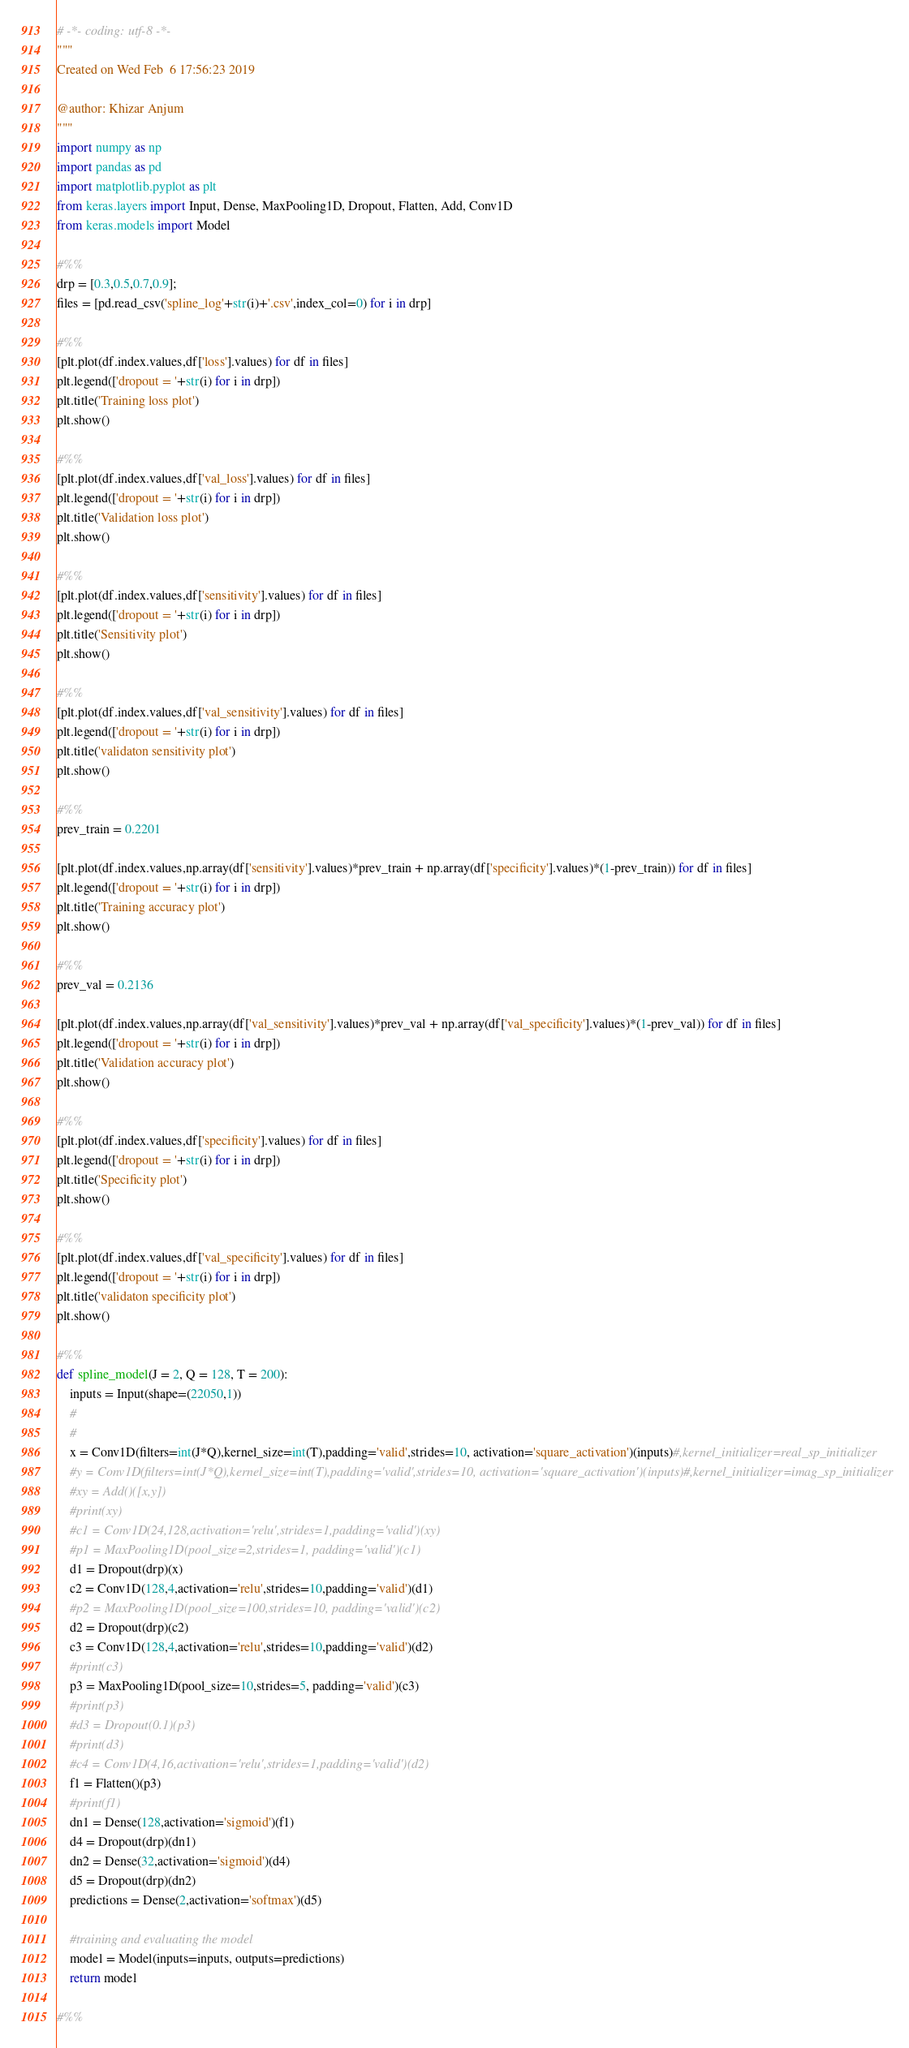Convert code to text. <code><loc_0><loc_0><loc_500><loc_500><_Python_># -*- coding: utf-8 -*-
"""
Created on Wed Feb  6 17:56:23 2019

@author: Khizar Anjum
"""
import numpy as np
import pandas as pd
import matplotlib.pyplot as plt
from keras.layers import Input, Dense, MaxPooling1D, Dropout, Flatten, Add, Conv1D
from keras.models import Model

#%%
drp = [0.3,0.5,0.7,0.9];
files = [pd.read_csv('spline_log'+str(i)+'.csv',index_col=0) for i in drp]

#%%
[plt.plot(df.index.values,df['loss'].values) for df in files]
plt.legend(['dropout = '+str(i) for i in drp])
plt.title('Training loss plot')
plt.show()

#%%
[plt.plot(df.index.values,df['val_loss'].values) for df in files]
plt.legend(['dropout = '+str(i) for i in drp])
plt.title('Validation loss plot')
plt.show()

#%%
[plt.plot(df.index.values,df['sensitivity'].values) for df in files]
plt.legend(['dropout = '+str(i) for i in drp])
plt.title('Sensitivity plot')
plt.show()

#%%
[plt.plot(df.index.values,df['val_sensitivity'].values) for df in files]
plt.legend(['dropout = '+str(i) for i in drp])
plt.title('validaton sensitivity plot')
plt.show()

#%%
prev_train = 0.2201

[plt.plot(df.index.values,np.array(df['sensitivity'].values)*prev_train + np.array(df['specificity'].values)*(1-prev_train)) for df in files]
plt.legend(['dropout = '+str(i) for i in drp])
plt.title('Training accuracy plot')
plt.show()

#%%
prev_val = 0.2136

[plt.plot(df.index.values,np.array(df['val_sensitivity'].values)*prev_val + np.array(df['val_specificity'].values)*(1-prev_val)) for df in files]
plt.legend(['dropout = '+str(i) for i in drp])
plt.title('Validation accuracy plot')
plt.show()

#%%
[plt.plot(df.index.values,df['specificity'].values) for df in files]
plt.legend(['dropout = '+str(i) for i in drp])
plt.title('Specificity plot')
plt.show()

#%%
[plt.plot(df.index.values,df['val_specificity'].values) for df in files]
plt.legend(['dropout = '+str(i) for i in drp])
plt.title('validaton specificity plot')
plt.show()

#%%
def spline_model(J = 2, Q = 128, T = 200):
    inputs = Input(shape=(22050,1))
    #
    #
    x = Conv1D(filters=int(J*Q),kernel_size=int(T),padding='valid',strides=10, activation='square_activation')(inputs)#,kernel_initializer=real_sp_initializer
    #y = Conv1D(filters=int(J*Q),kernel_size=int(T),padding='valid',strides=10, activation='square_activation')(inputs)#,kernel_initializer=imag_sp_initializer
    #xy = Add()([x,y])
    #print(xy)
    #c1 = Conv1D(24,128,activation='relu',strides=1,padding='valid')(xy)
    #p1 = MaxPooling1D(pool_size=2,strides=1, padding='valid')(c1)
    d1 = Dropout(drp)(x)
    c2 = Conv1D(128,4,activation='relu',strides=10,padding='valid')(d1)
    #p2 = MaxPooling1D(pool_size=100,strides=10, padding='valid')(c2)
    d2 = Dropout(drp)(c2)
    c3 = Conv1D(128,4,activation='relu',strides=10,padding='valid')(d2)
    #print(c3)
    p3 = MaxPooling1D(pool_size=10,strides=5, padding='valid')(c3)
    #print(p3)
    #d3 = Dropout(0.1)(p3)
    #print(d3)
    #c4 = Conv1D(4,16,activation='relu',strides=1,padding='valid')(d2)
    f1 = Flatten()(p3)
    #print(f1)
    dn1 = Dense(128,activation='sigmoid')(f1)
    d4 = Dropout(drp)(dn1)
    dn2 = Dense(32,activation='sigmoid')(d4)
    d5 = Dropout(drp)(dn2)
    predictions = Dense(2,activation='softmax')(d5)
    
    #training and evaluating the model
    model = Model(inputs=inputs, outputs=predictions)
    return model

#%%</code> 